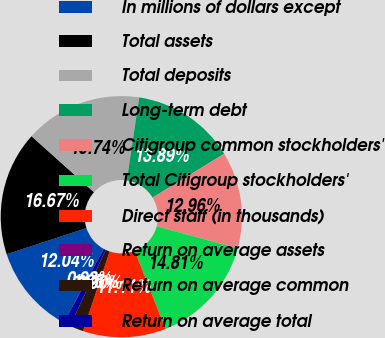Convert chart. <chart><loc_0><loc_0><loc_500><loc_500><pie_chart><fcel>In millions of dollars except<fcel>Total assets<fcel>Total deposits<fcel>Long-term debt<fcel>Citigroup common stockholders'<fcel>Total Citigroup stockholders'<fcel>Direct staff (in thousands)<fcel>Return on average assets<fcel>Return on average common<fcel>Return on average total<nl><fcel>12.04%<fcel>16.67%<fcel>15.74%<fcel>13.89%<fcel>12.96%<fcel>14.81%<fcel>11.11%<fcel>0.0%<fcel>1.85%<fcel>0.93%<nl></chart> 